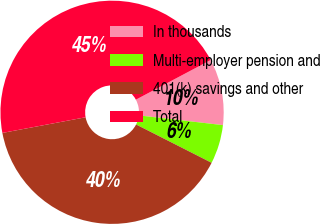Convert chart. <chart><loc_0><loc_0><loc_500><loc_500><pie_chart><fcel>In thousands<fcel>Multi-employer pension and<fcel>401(k) savings and other<fcel>Total<nl><fcel>9.59%<fcel>5.64%<fcel>39.56%<fcel>45.2%<nl></chart> 